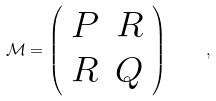Convert formula to latex. <formula><loc_0><loc_0><loc_500><loc_500>\mathcal { M } = \left ( \begin{array} { c c } P & R \\ R & Q \end{array} \right ) \quad ,</formula> 